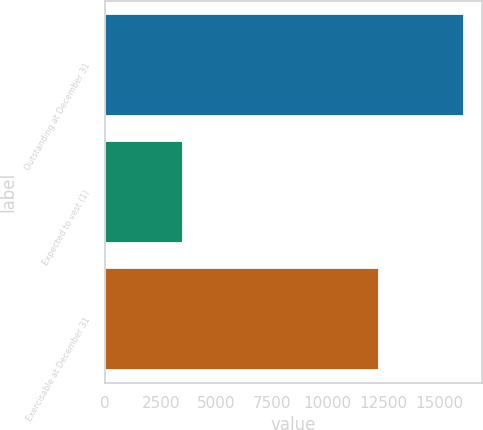Convert chart. <chart><loc_0><loc_0><loc_500><loc_500><bar_chart><fcel>Outstanding at December 31<fcel>Expected to vest (1)<fcel>Exercisable at December 31<nl><fcel>16121<fcel>3499<fcel>12299<nl></chart> 